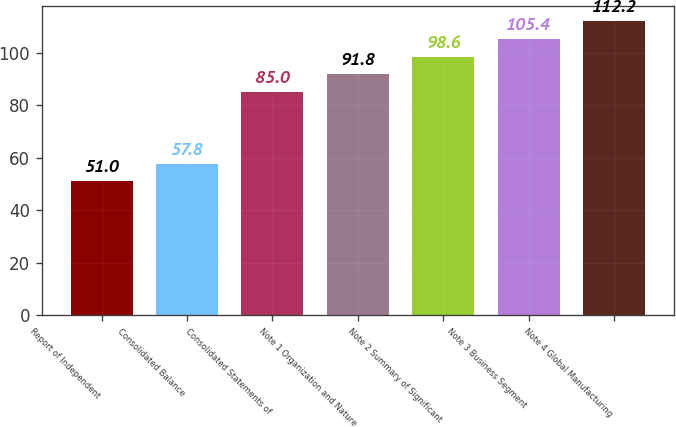<chart> <loc_0><loc_0><loc_500><loc_500><bar_chart><fcel>Report of Independent<fcel>Consolidated Balance<fcel>Consolidated Statements of<fcel>Note 1 Organization and Nature<fcel>Note 2 Summary of Significant<fcel>Note 3 Business Segment<fcel>Note 4 Global Manufacturing<nl><fcel>51<fcel>57.8<fcel>85<fcel>91.8<fcel>98.6<fcel>105.4<fcel>112.2<nl></chart> 